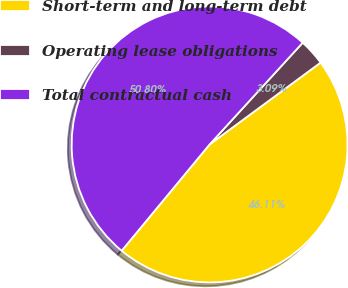Convert chart. <chart><loc_0><loc_0><loc_500><loc_500><pie_chart><fcel>Short-term and long-term debt<fcel>Operating lease obligations<fcel>Total contractual cash<nl><fcel>46.11%<fcel>3.09%<fcel>50.79%<nl></chart> 